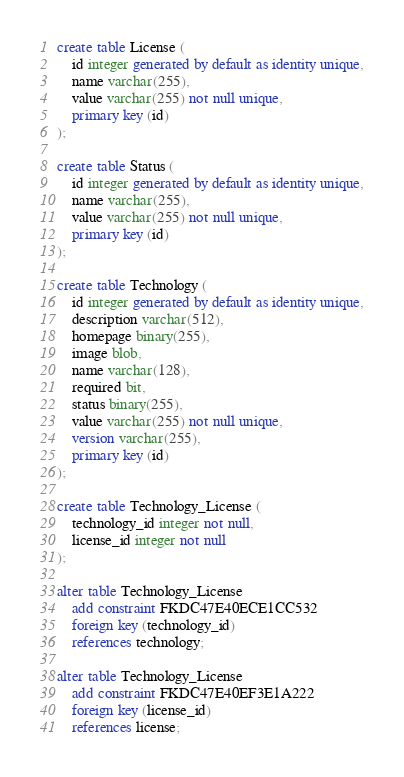Convert code to text. <code><loc_0><loc_0><loc_500><loc_500><_SQL_>create table License (
    id integer generated by default as identity unique,
    name varchar(255),
    value varchar(255) not null unique,
    primary key (id)
);

create table Status (
    id integer generated by default as identity unique,
    name varchar(255),
    value varchar(255) not null unique,
    primary key (id)
);

create table Technology (
    id integer generated by default as identity unique,
    description varchar(512),
    homepage binary(255),
    image blob,
    name varchar(128),
    required bit,
    status binary(255),
    value varchar(255) not null unique,
    version varchar(255),
    primary key (id)
);

create table Technology_License (
    technology_id integer not null,
    license_id integer not null
);

alter table Technology_License 
    add constraint FKDC47E40ECE1CC532 
    foreign key (technology_id) 
    references technology;

alter table Technology_License 
    add constraint FKDC47E40EF3E1A222 
    foreign key (license_id) 
    references license;</code> 